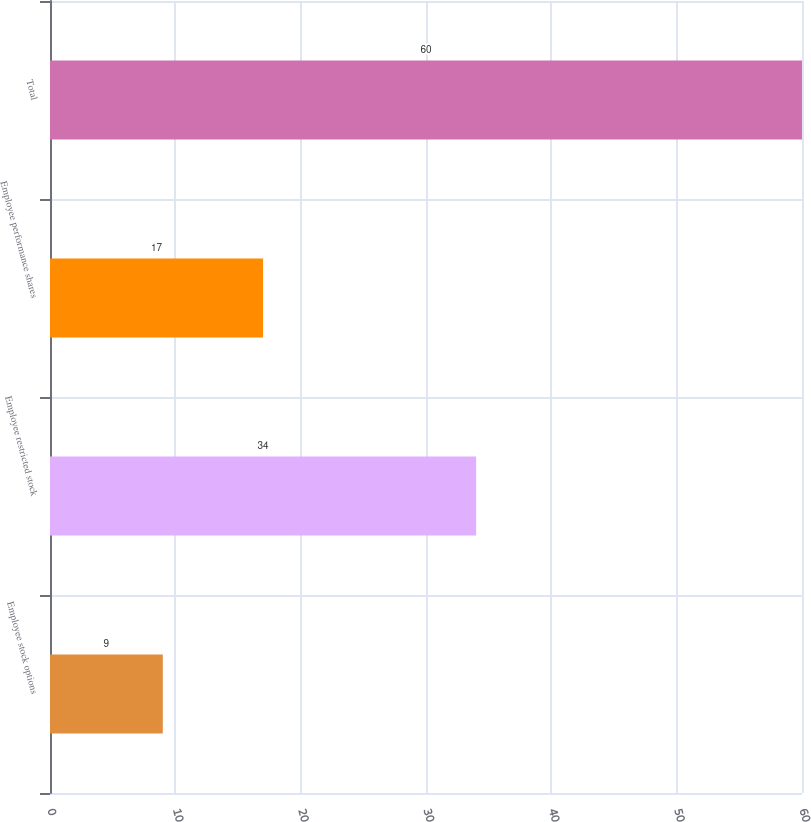Convert chart to OTSL. <chart><loc_0><loc_0><loc_500><loc_500><bar_chart><fcel>Employee stock options<fcel>Employee restricted stock<fcel>Employee performance shares<fcel>Total<nl><fcel>9<fcel>34<fcel>17<fcel>60<nl></chart> 